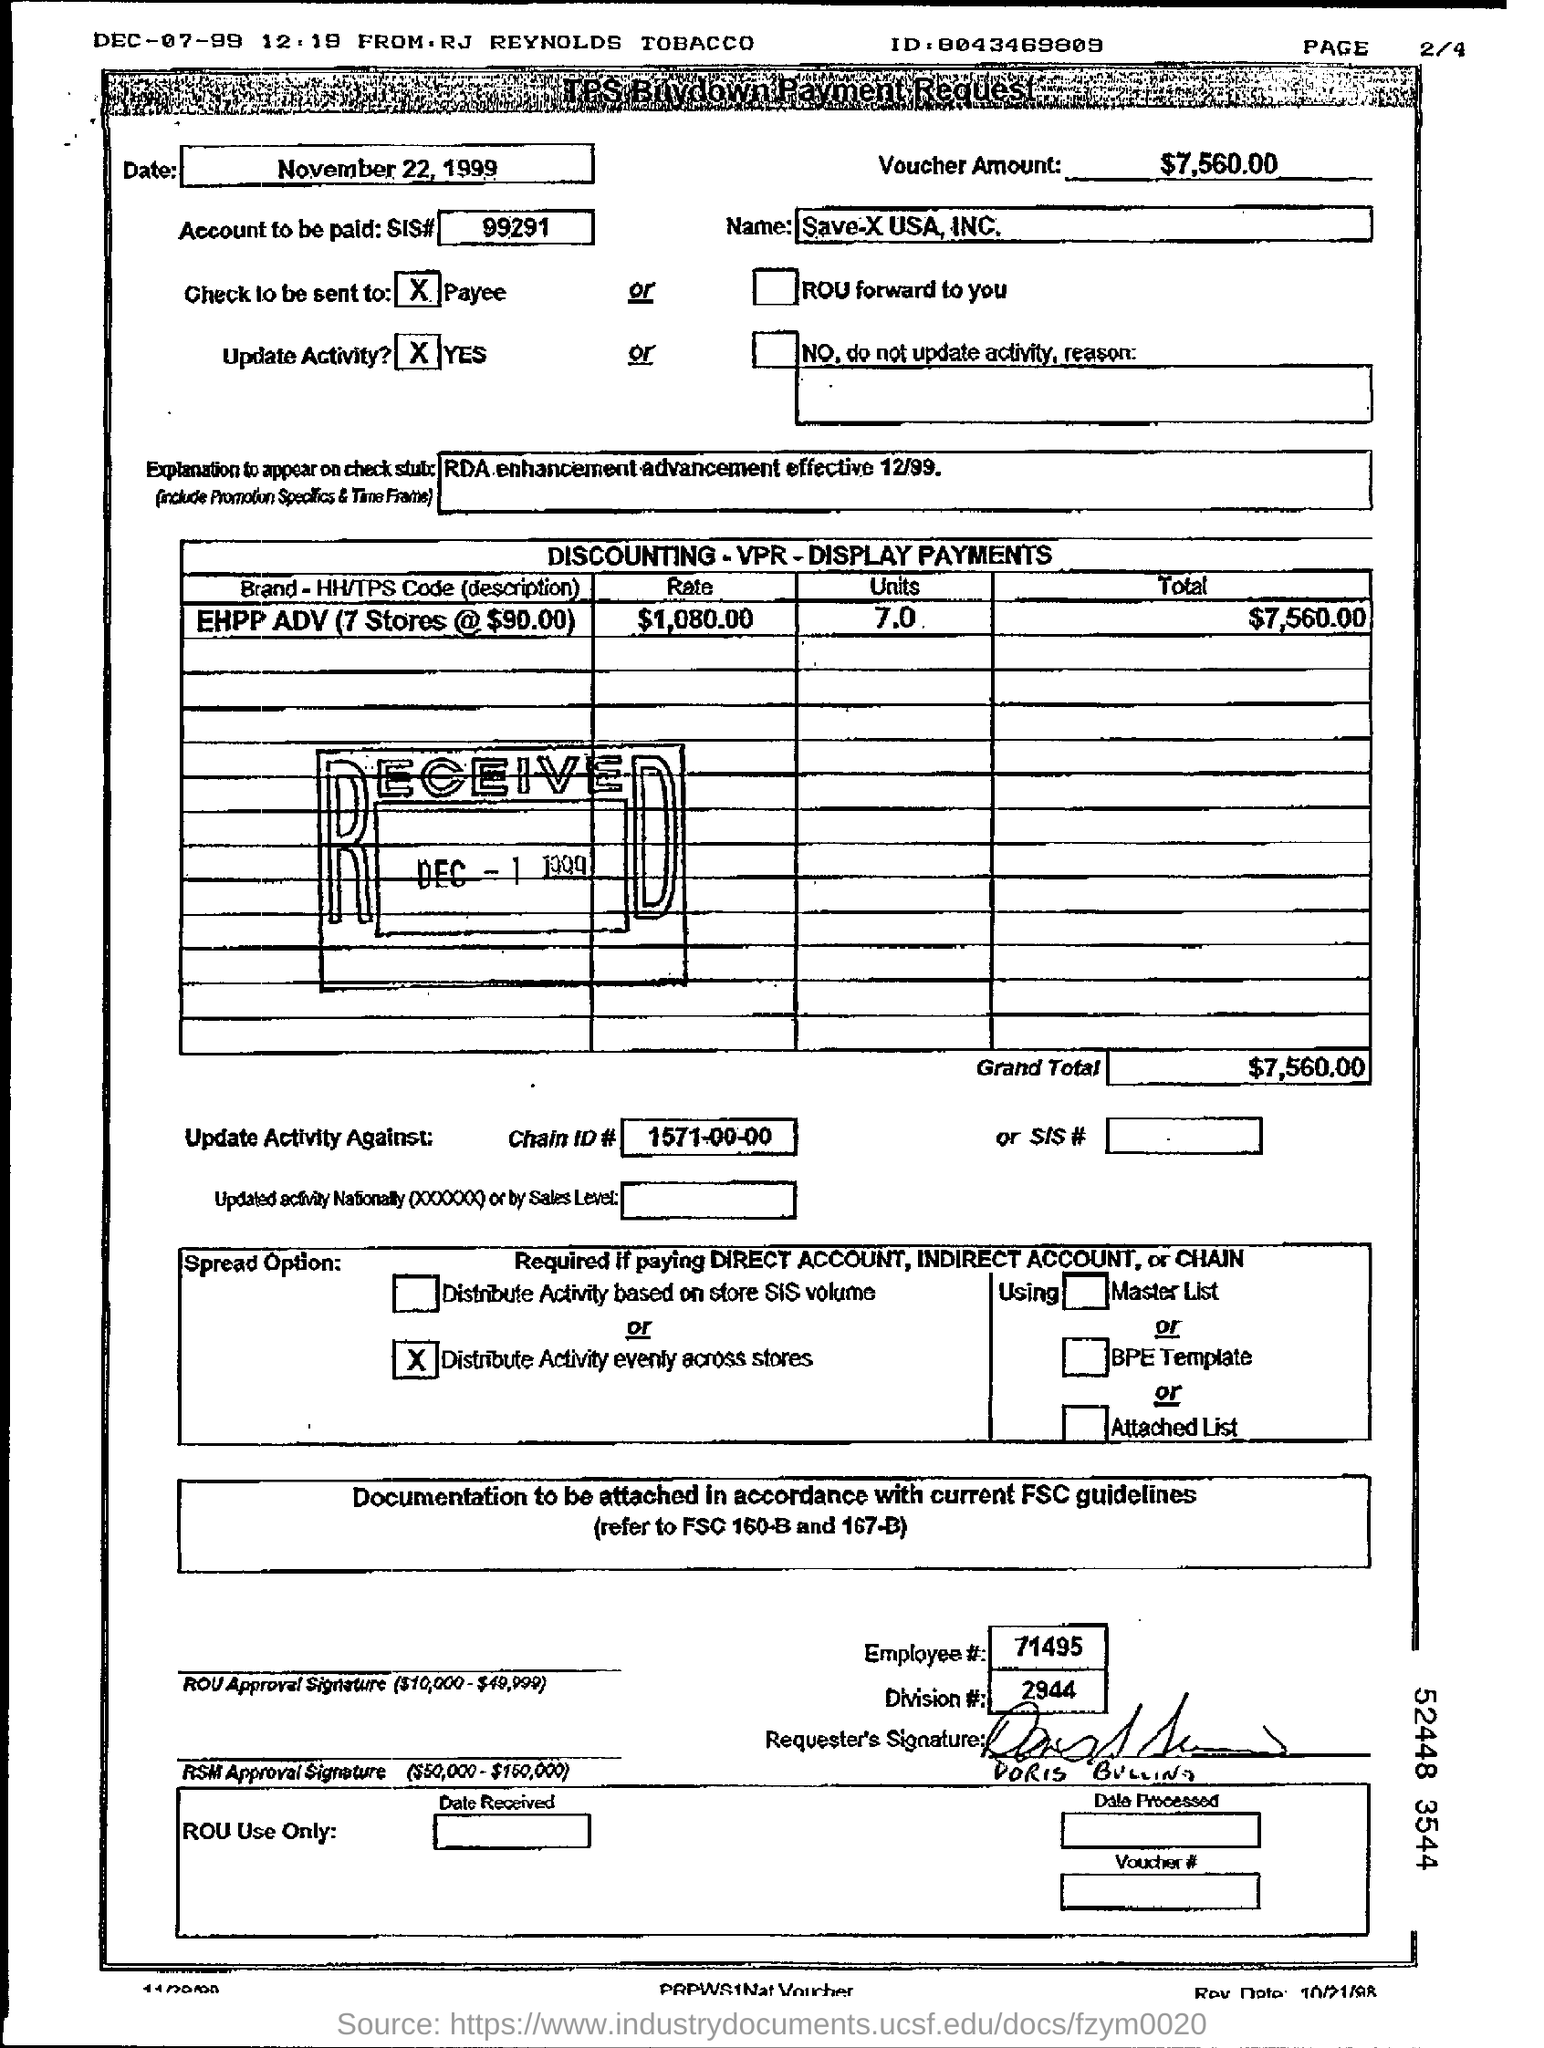Indicate a few pertinent items in this graphic. The name of the entity making the TPS buy-down payment request is Save-X USA, INC. The cost for the Early Head Start and Head Start Program Administered by the Evelyn Mack Academy (7 stores at $90.00) is 7 units. The rate for the EHPP ADV (7 stores at $90.00 each) is $1,080.00. What is the chain ID# in the payment request? It is 1571-00-00. The voucher is valued at $7,560.00. 